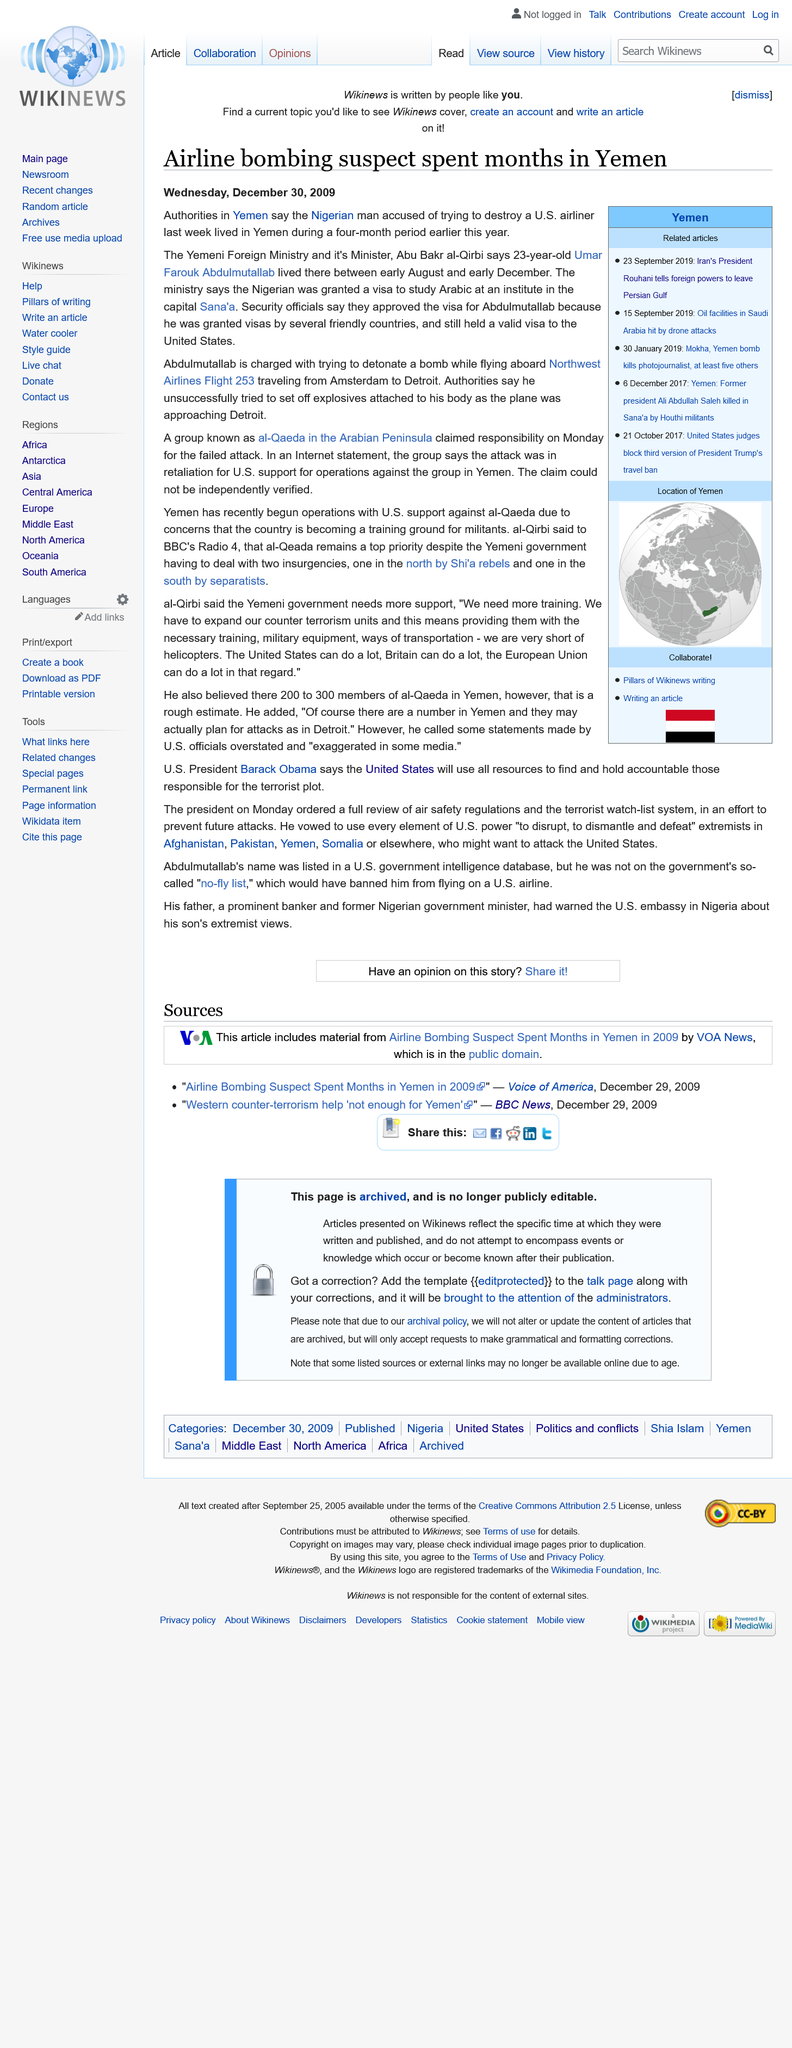Give some essential details in this illustration. Umar Farouk Abdulmutallab lived in Yemen between August and December of 2010. The suspect in the airline bombing was of Nigerian nationality, and the airline in question was also Nigerian. Northwest Airlines Flight 253 was traveling from Amsterdam to Detroit when it was intercepted by security personnel due to suspicious behavior by a passenger. 